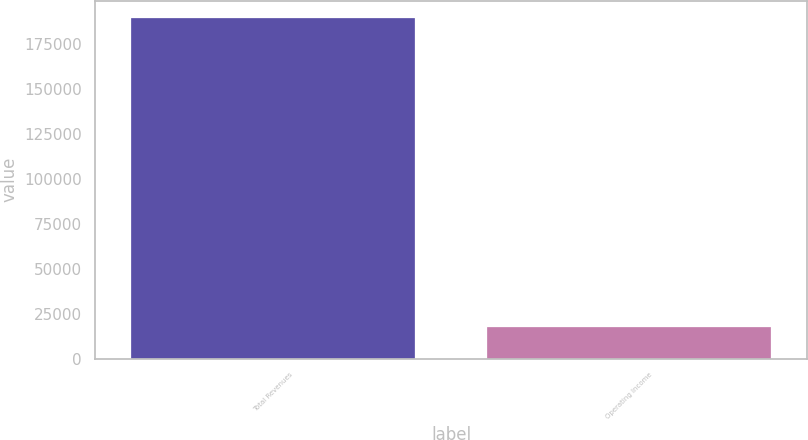Convert chart to OTSL. <chart><loc_0><loc_0><loc_500><loc_500><bar_chart><fcel>Total Revenues<fcel>Operating Income<nl><fcel>189313<fcel>17460<nl></chart> 